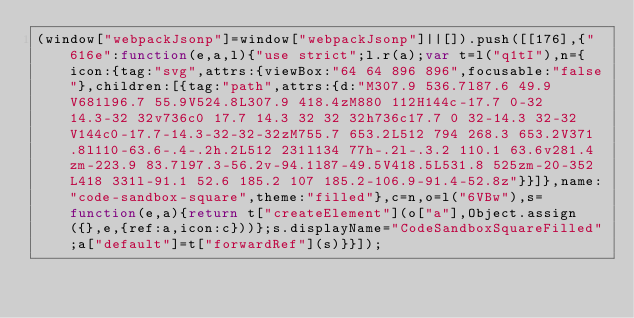Convert code to text. <code><loc_0><loc_0><loc_500><loc_500><_JavaScript_>(window["webpackJsonp"]=window["webpackJsonp"]||[]).push([[176],{"616e":function(e,a,l){"use strict";l.r(a);var t=l("q1tI"),n={icon:{tag:"svg",attrs:{viewBox:"64 64 896 896",focusable:"false"},children:[{tag:"path",attrs:{d:"M307.9 536.7l87.6 49.9V681l96.7 55.9V524.8L307.9 418.4zM880 112H144c-17.7 0-32 14.3-32 32v736c0 17.7 14.3 32 32 32h736c17.7 0 32-14.3 32-32V144c0-17.7-14.3-32-32-32zM755.7 653.2L512 794 268.3 653.2V371.8l110-63.6-.4-.2h.2L512 231l134 77h-.2l-.3.2 110.1 63.6v281.4zm-223.9 83.7l97.3-56.2v-94.1l87-49.5V418.5L531.8 525zm-20-352L418 331l-91.1 52.6 185.2 107 185.2-106.9-91.4-52.8z"}}]},name:"code-sandbox-square",theme:"filled"},c=n,o=l("6VBw"),s=function(e,a){return t["createElement"](o["a"],Object.assign({},e,{ref:a,icon:c}))};s.displayName="CodeSandboxSquareFilled";a["default"]=t["forwardRef"](s)}}]);</code> 